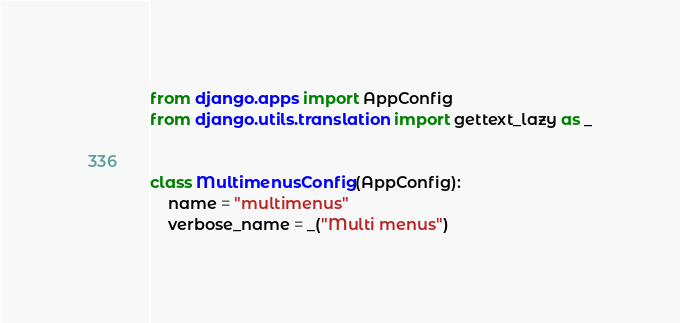Convert code to text. <code><loc_0><loc_0><loc_500><loc_500><_Python_>from django.apps import AppConfig
from django.utils.translation import gettext_lazy as _


class MultimenusConfig(AppConfig):
    name = "multimenus"
    verbose_name = _("Multi menus")
</code> 